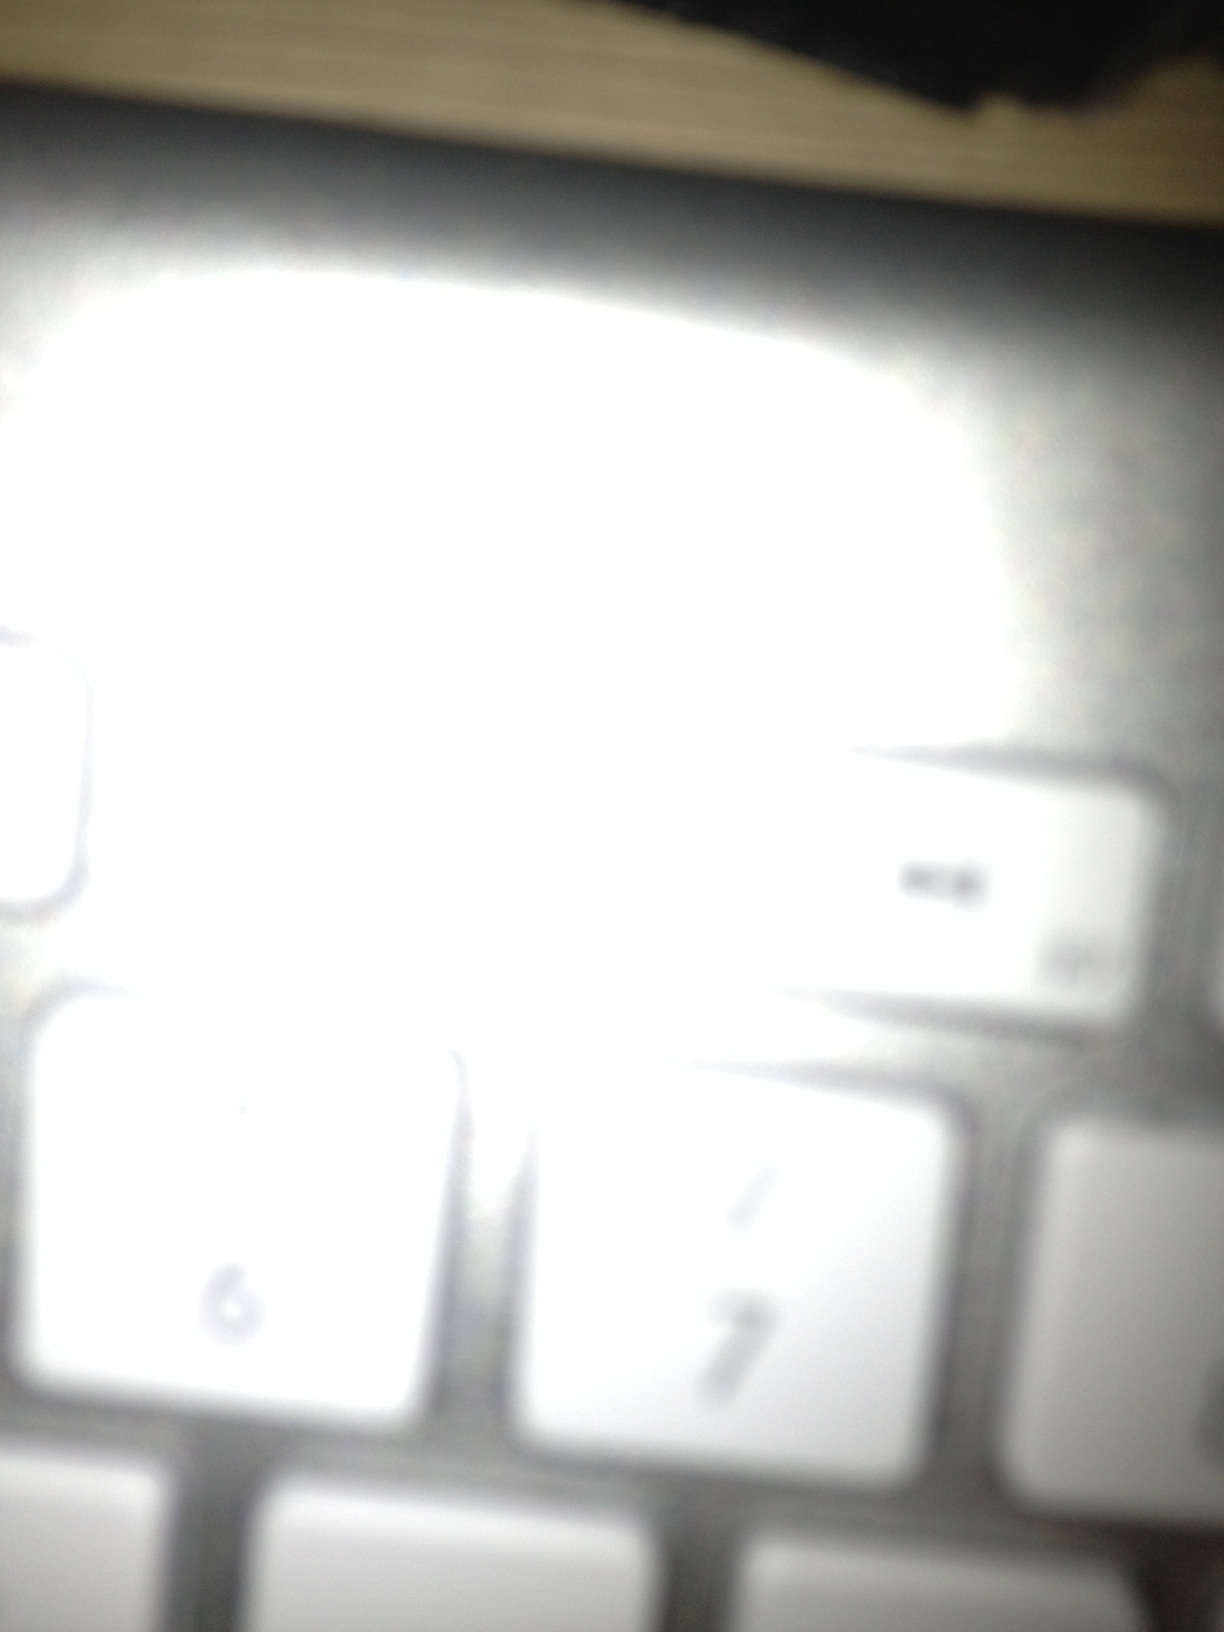What is it? This appears to be an image of a part of a keyboard, though it is quite blurry and overexposed. The visible keys include the numbers 6 and 7. 